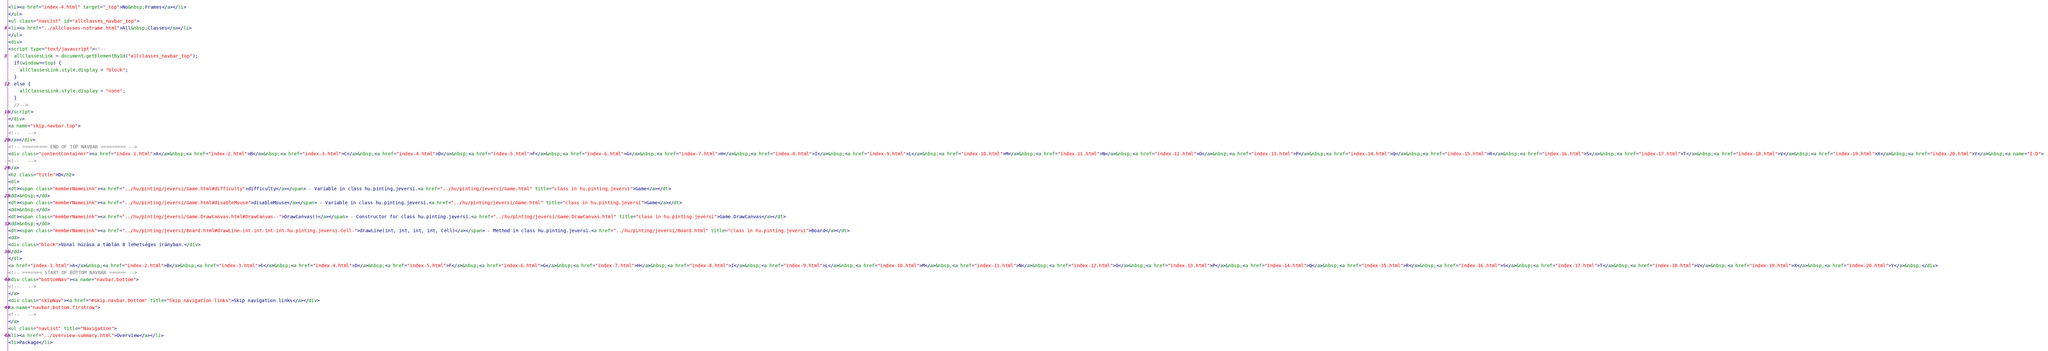Convert code to text. <code><loc_0><loc_0><loc_500><loc_500><_HTML_><li><a href="index-4.html" target="_top">No&nbsp;Frames</a></li>
</ul>
<ul class="navList" id="allclasses_navbar_top">
<li><a href="../allclasses-noframe.html">All&nbsp;Classes</a></li>
</ul>
<div>
<script type="text/javascript"><!--
  allClassesLink = document.getElementById("allclasses_navbar_top");
  if(window==top) {
    allClassesLink.style.display = "block";
  }
  else {
    allClassesLink.style.display = "none";
  }
  //-->
</script>
</div>
<a name="skip.navbar.top">
<!--   -->
</a></div>
<!-- ========= END OF TOP NAVBAR ========= -->
<div class="contentContainer"><a href="index-1.html">A</a>&nbsp;<a href="index-2.html">B</a>&nbsp;<a href="index-3.html">C</a>&nbsp;<a href="index-4.html">D</a>&nbsp;<a href="index-5.html">F</a>&nbsp;<a href="index-6.html">G</a>&nbsp;<a href="index-7.html">H</a>&nbsp;<a href="index-8.html">I</a>&nbsp;<a href="index-9.html">L</a>&nbsp;<a href="index-10.html">M</a>&nbsp;<a href="index-11.html">N</a>&nbsp;<a href="index-12.html">O</a>&nbsp;<a href="index-13.html">P</a>&nbsp;<a href="index-14.html">Q</a>&nbsp;<a href="index-15.html">R</a>&nbsp;<a href="index-16.html">S</a>&nbsp;<a href="index-17.html">T</a>&nbsp;<a href="index-18.html">V</a>&nbsp;<a href="index-19.html">X</a>&nbsp;<a href="index-20.html">Y</a>&nbsp;<a name="I:D">
<!--   -->
</a>
<h2 class="title">D</h2>
<dl>
<dt><span class="memberNameLink"><a href="../hu/pinting/jeversi/Game.html#difficulty">difficulty</a></span> - Variable in class hu.pinting.jeversi.<a href="../hu/pinting/jeversi/Game.html" title="class in hu.pinting.jeversi">Game</a></dt>
<dd>&nbsp;</dd>
<dt><span class="memberNameLink"><a href="../hu/pinting/jeversi/Game.html#disableMouse">disableMouse</a></span> - Variable in class hu.pinting.jeversi.<a href="../hu/pinting/jeversi/Game.html" title="class in hu.pinting.jeversi">Game</a></dt>
<dd>&nbsp;</dd>
<dt><span class="memberNameLink"><a href="../hu/pinting/jeversi/Game.DrawCanvas.html#DrawCanvas--">DrawCanvas()</a></span> - Constructor for class hu.pinting.jeversi.<a href="../hu/pinting/jeversi/Game.DrawCanvas.html" title="class in hu.pinting.jeversi">Game.DrawCanvas</a></dt>
<dd>&nbsp;</dd>
<dt><span class="memberNameLink"><a href="../hu/pinting/jeversi/Board.html#drawLine-int-int-int-int-hu.pinting.jeversi.Cell-">drawLine(int, int, int, int, Cell)</a></span> - Method in class hu.pinting.jeversi.<a href="../hu/pinting/jeversi/Board.html" title="class in hu.pinting.jeversi">Board</a></dt>
<dd>
<div class="block">Vonal húzása a táblán 8 lehetséges irányban.</div>
</dd>
</dl>
<a href="index-1.html">A</a>&nbsp;<a href="index-2.html">B</a>&nbsp;<a href="index-3.html">C</a>&nbsp;<a href="index-4.html">D</a>&nbsp;<a href="index-5.html">F</a>&nbsp;<a href="index-6.html">G</a>&nbsp;<a href="index-7.html">H</a>&nbsp;<a href="index-8.html">I</a>&nbsp;<a href="index-9.html">L</a>&nbsp;<a href="index-10.html">M</a>&nbsp;<a href="index-11.html">N</a>&nbsp;<a href="index-12.html">O</a>&nbsp;<a href="index-13.html">P</a>&nbsp;<a href="index-14.html">Q</a>&nbsp;<a href="index-15.html">R</a>&nbsp;<a href="index-16.html">S</a>&nbsp;<a href="index-17.html">T</a>&nbsp;<a href="index-18.html">V</a>&nbsp;<a href="index-19.html">X</a>&nbsp;<a href="index-20.html">Y</a>&nbsp;</div>
<!-- ======= START OF BOTTOM NAVBAR ====== -->
<div class="bottomNav"><a name="navbar.bottom">
<!--   -->
</a>
<div class="skipNav"><a href="#skip.navbar.bottom" title="Skip navigation links">Skip navigation links</a></div>
<a name="navbar.bottom.firstrow">
<!--   -->
</a>
<ul class="navList" title="Navigation">
<li><a href="../overview-summary.html">Overview</a></li>
<li>Package</li></code> 